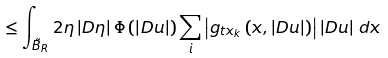<formula> <loc_0><loc_0><loc_500><loc_500>\leq \int _ { \tilde { B } _ { R } } 2 \eta \left | D \eta \right | \Phi \left ( \left | D u \right | \right ) \sum _ { i } \left | g _ { t x _ { k } } \left ( x , \left | D u \right | \right ) \right | \left | D u \right | \, d x</formula> 